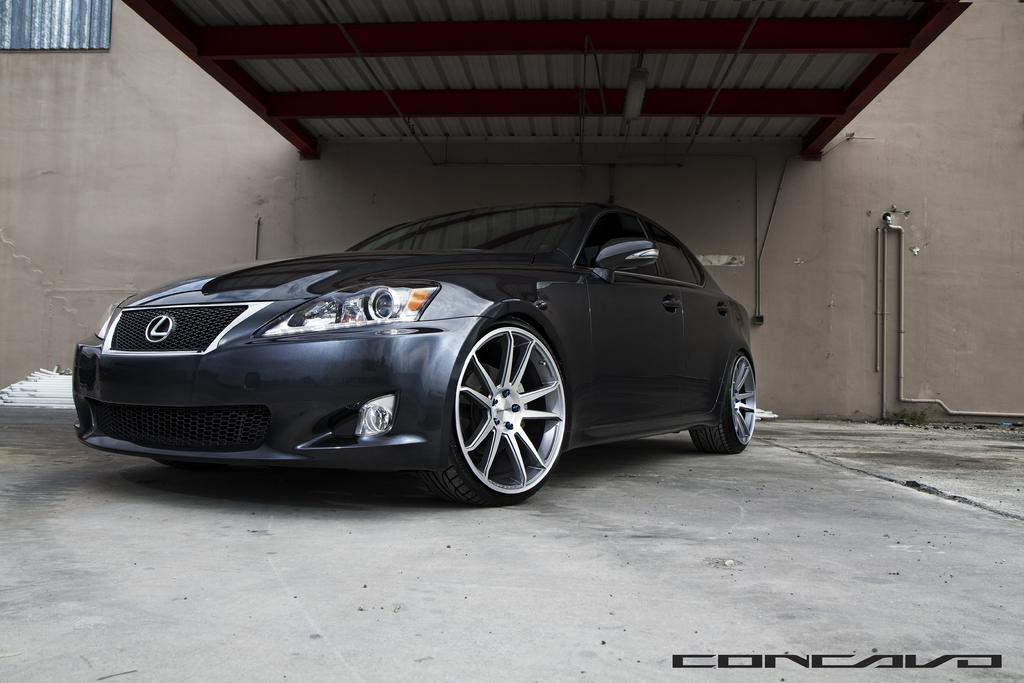What is the main subject of the image? There is a car in the image. Where is the car located in the image? The car is under a shed. What can be seen in the background of the image? There is a wall in the background of the image. What else is visible in the image besides the car and wall? There are pipes on the right side of the image. What type of cub is playing with the appliance in the image? There is no cub or appliance present in the image. Can you hear the car in the image? The image is a still picture, so it does not contain any sound. 